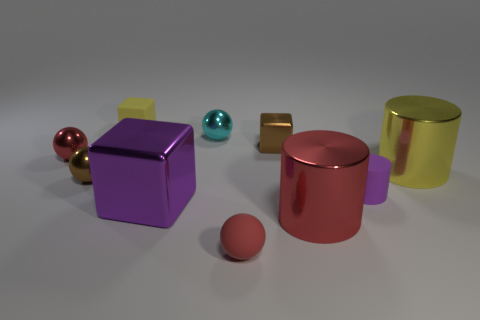What is the color of the block that is the same material as the big purple object? The block that shares the same glossy material as the big purple cube is actually golden, not brown. Its reflective surface and the lighting in the scene may affect color perception, but its primary color is gold. 